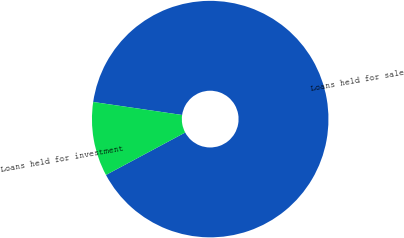<chart> <loc_0><loc_0><loc_500><loc_500><pie_chart><fcel>Loans held for sale<fcel>Loans held for investment<nl><fcel>89.86%<fcel>10.14%<nl></chart> 